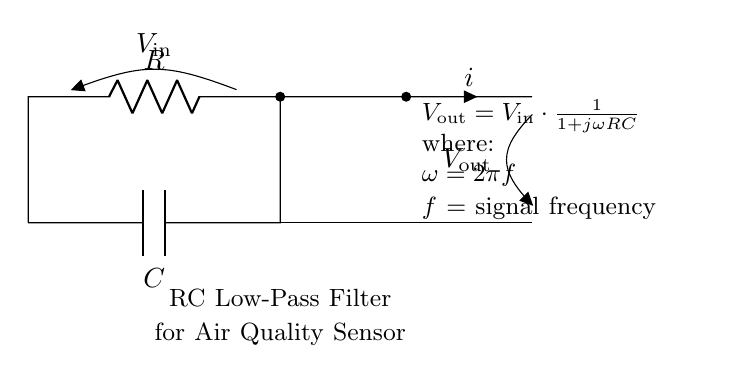What type of filter is represented in the circuit? The circuit is an RC Low-Pass Filter, indicated by the labeling in the diagram. A low-pass filter allows low-frequency signals to pass while attenuating high-frequency signals, which is essential for smoothing the air quality sensor data.
Answer: RC Low-Pass Filter What are the components used in the circuit? The circuit consists of a resistor (R) and a capacitor (C), as labeled in the diagram. These are the basic components of an RC circuit, which are crucial for creating the filter behavior.
Answer: Resistor and Capacitor What does V out depend on in this circuit? V out depends on V in and the values of R and C, as per the equation provided in the diagram. The output voltage is a function of the input voltage modified by the frequency response of the RC circuit.
Answer: V in, R, and C What is the relationship between the input frequency and the output voltage? The output voltage decreases as the input frequency increases due to the frequency response of the low-pass filter. The equation illustrates this by showing that as frequency increases, the term involving jωRC dominates, reducing V out.
Answer: Decreases with increasing frequency What is the formula for V out given in the circuit? The formula provided in the circuit is V out = V in * (1 / (1 + jωRC)). This represents the mathematical relationship defining how the output voltage changes based on the input voltage, resistance, capacitance, and signal frequency.
Answer: V out = V in * (1 / (1 + jωRC)) What is the current labeled in the circuit? The current is labeled as "i" in the diagram, indicating the flow of electric charge through the circuit, which is influenced by the resistor and capacitor as per Ohm's Law and the capacitance relationships.
Answer: i How does the capacitor behave at high frequencies in this circuit? At high frequencies, the capacitor acts as a short circuit, leading to decreased output voltage. This is because the impedance of the capacitor decreases with increasing frequency, allowing most of the AC signal to bypass the output.
Answer: Acts as a short circuit 